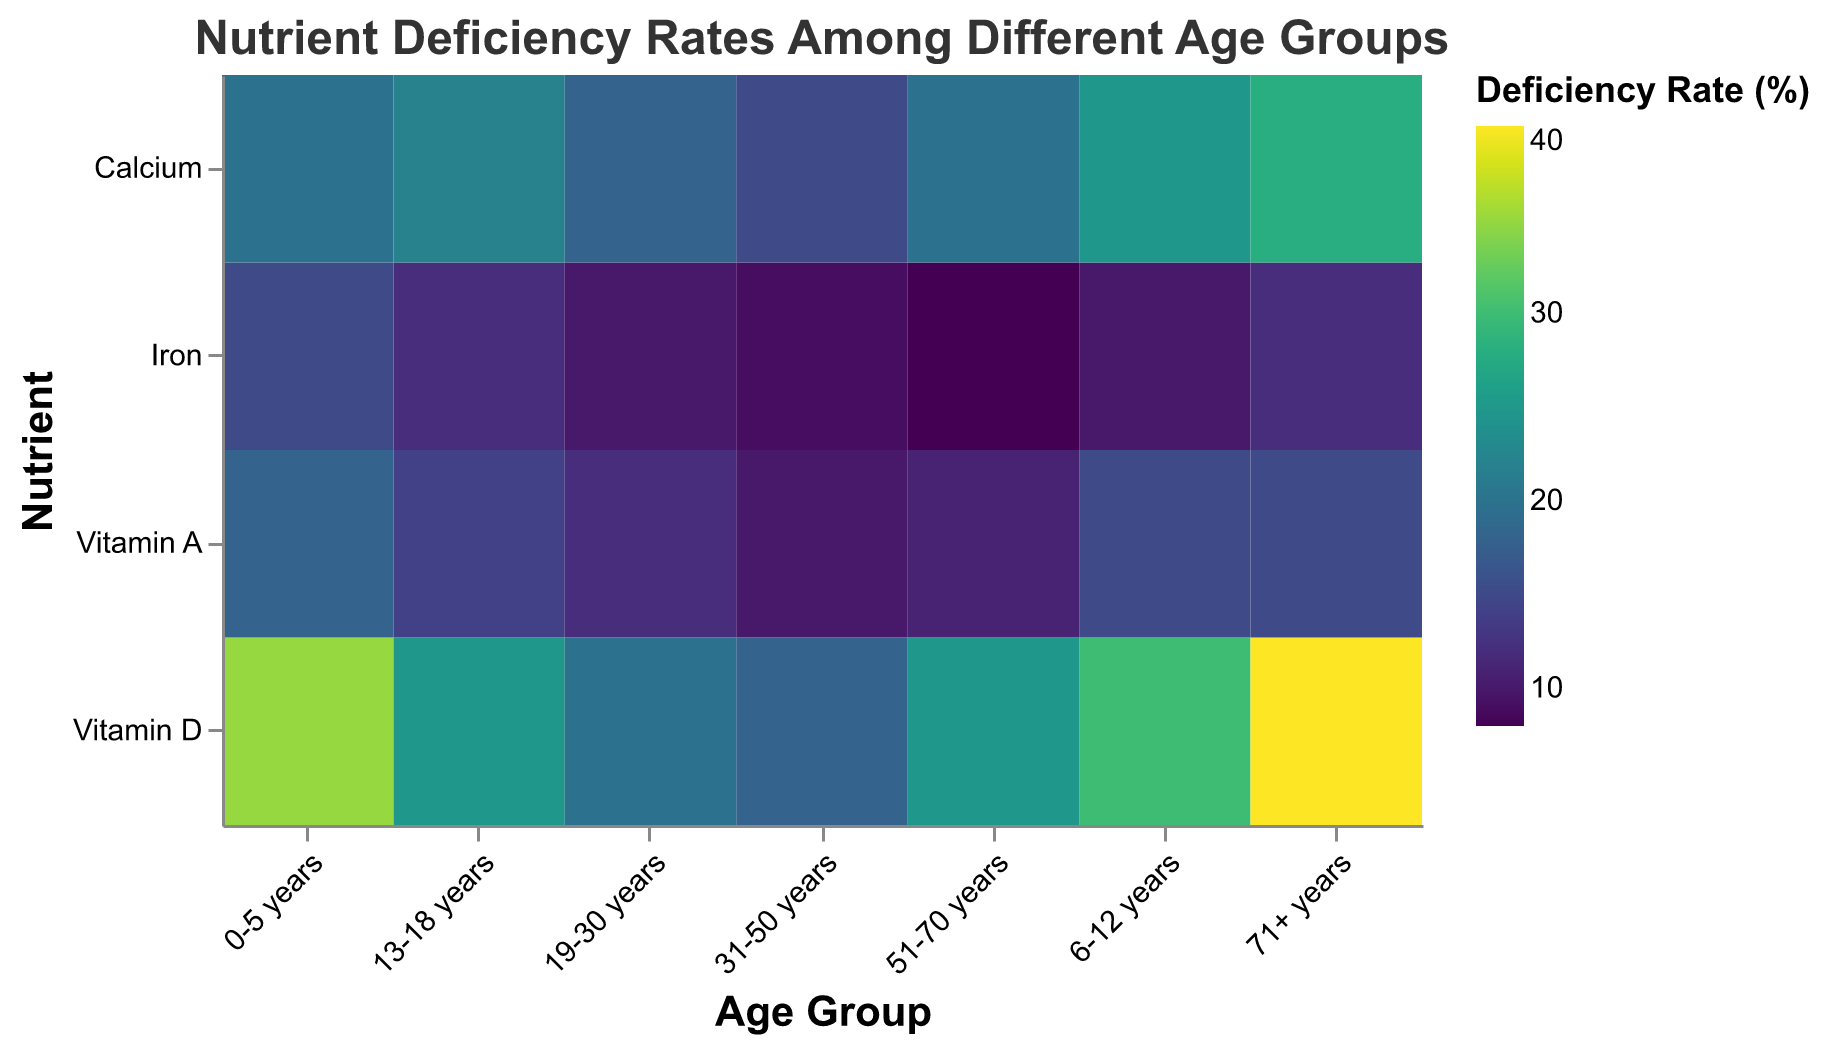What is the title of the heatmap? The title is located at the top of the figure, it states what the heatmap represents.
Answer: Nutrient Deficiency Rates Among Different Age Groups Which age group shows the highest deficiency rate for Vitamin D? Look for the cell under the "Vitamin D" row and see which age group has the darkest color or the highest percentage.
Answer: 71+ years Which nutrient has the lowest deficiency rate in the 31-50 years age group? In the column for "31-50 years", find the cell with the lightest color, which signifies the lowest deficiency rate.
Answer: Iron Compare the deficiency rates of Calcium and Vitamin A in the 19-30 years age group. Which one is higher? Look at the "19-30 years" column and compare the cells for "Calcium" and "Vitamin A" by their color intensity or stated percentage values.
Answer: Calcium What is the average deficiency rate of Calcium across all age groups? Sum the deficiency rates of Calcium across all age groups and then divide by the number of age groups (7). ≈ (20 + 25 + 22 + 18 + 15 + 20 + 28) / 7 = 148 / 7 ≈ 21.14
Answer: ≈21.14 Which age group has the overall highest nutrient deficiency rate for any nutrient and what is the rate? Identify the darkest or most saturated cell in the entire heatmap and check the age group and nutrient it corresponds to.
Answer: 71+ years for Vitamin D, 40% Describe the trend in Iron deficiency rates as the age group increases. Observe the color gradient in the "Iron" row from left (youngest) to right (oldest) age groups and characterize the pattern (increasing, decreasing, stable).
Answer: Generally decreasing How does the deficiency rate of Vitamin A in the 0-5 years age group compare to the rate in the 13-18 years age group? Find the cells for "Vitamin A" in the columns "0-5 years" and "13-18 years" and compare the values.
Answer: 0-5 years is higher Which nutrient shows the most significant variability in deficiency rates across different age groups? Scan each row, comparing the range of colors or the numerical range of deficiency rates and identify the nutrient with the widest range of values.
Answer: Vitamin D 